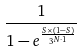Convert formula to latex. <formula><loc_0><loc_0><loc_500><loc_500>\frac { 1 } { 1 - e ^ { \frac { S \times ( 1 - S ) } { 3 ^ { N \cdot 1 } } } }</formula> 